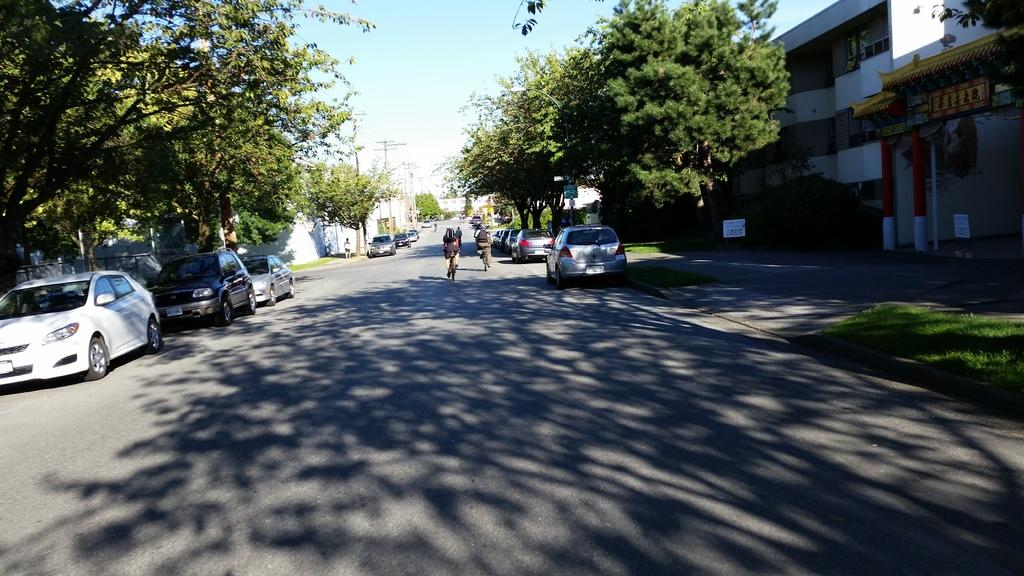What are the people in the image doing? The people in the image are riding bicycles on the road. Can you describe the person who is not riding a bicycle? There is a person standing in the image. What type of vehicles can be seen in the image? Cars are visible in the image. What natural elements are present in the image? Trees and grass are visible in the image. What type of structure can be seen in the image? There is an arch and a building in the image. What architectural features are present in the image? Pillars are present in the image. What additional objects can be seen in the image? Boards are visible in the image. What type of eggnog is being served at the team event in the image? There is no team event or eggnog present in the image. What color is the shirt worn by the person standing in the image? The provided facts do not mention the color of any shirts in the image. 